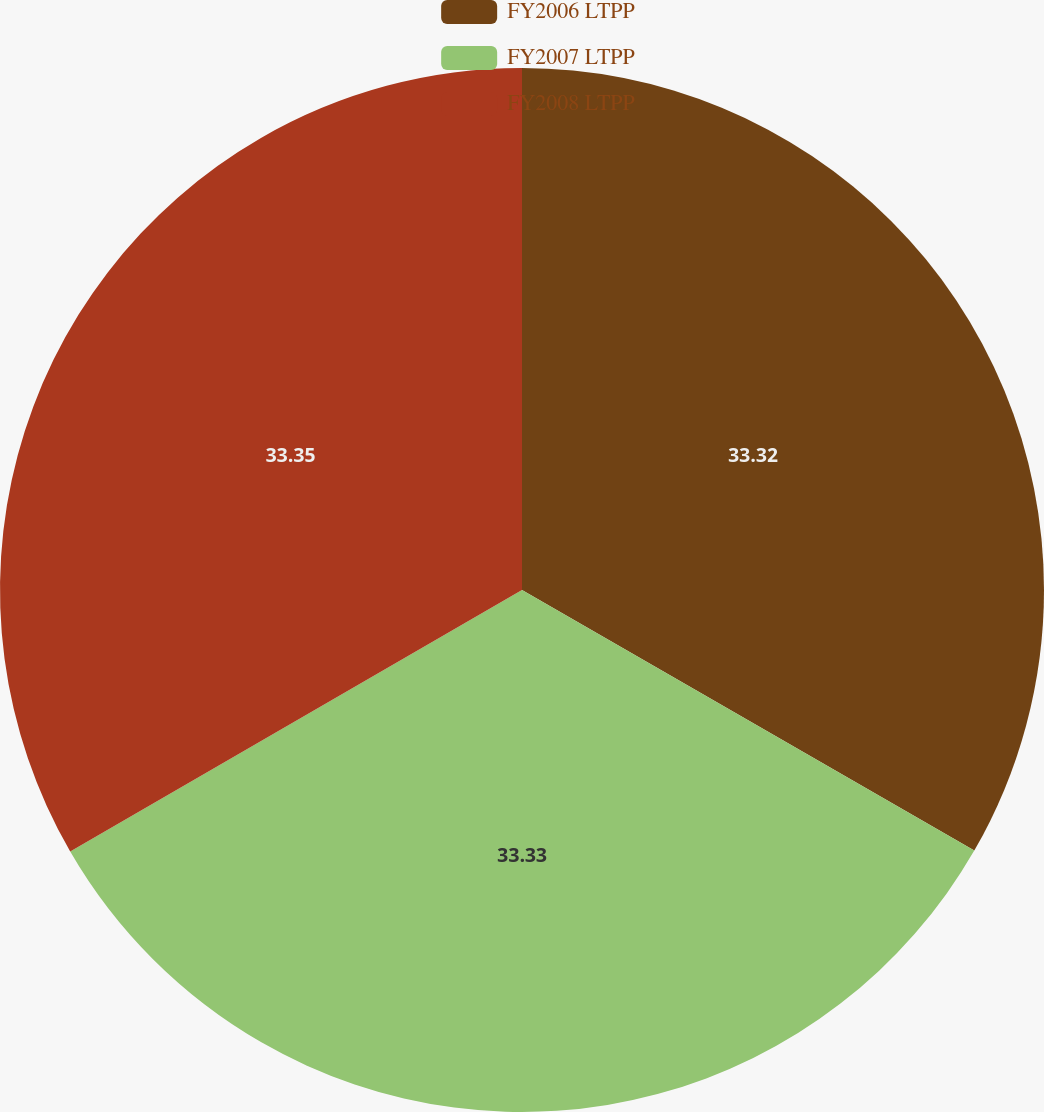Convert chart. <chart><loc_0><loc_0><loc_500><loc_500><pie_chart><fcel>FY2006 LTPP<fcel>FY2007 LTPP<fcel>FY2008 LTPP<nl><fcel>33.32%<fcel>33.33%<fcel>33.35%<nl></chart> 